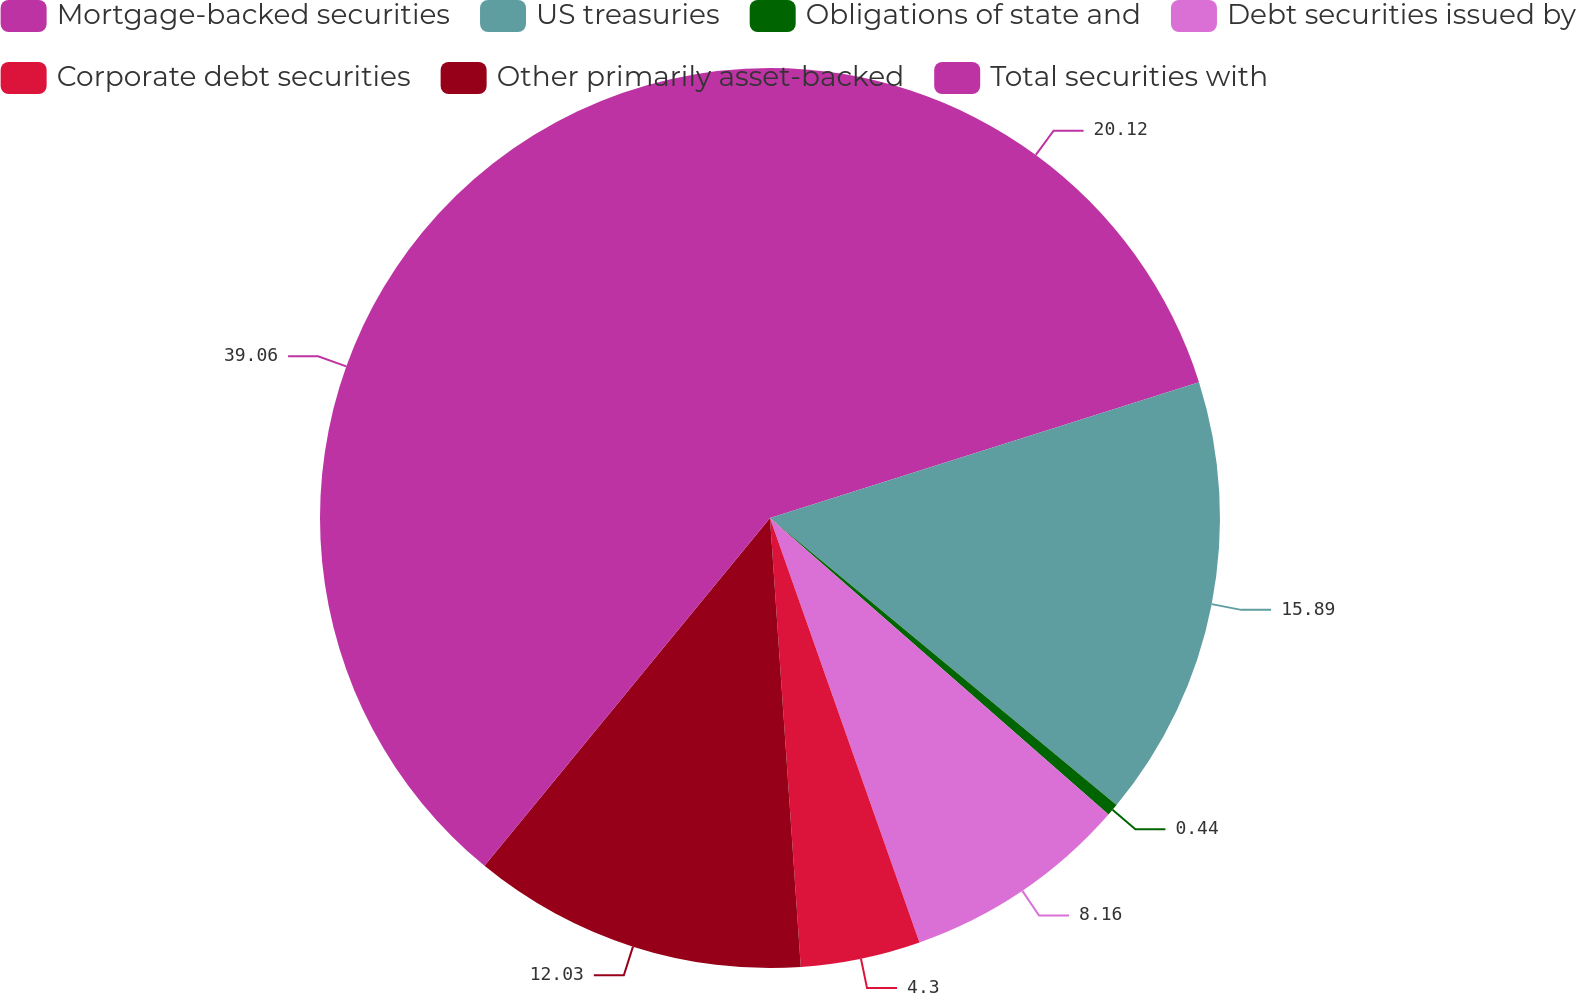<chart> <loc_0><loc_0><loc_500><loc_500><pie_chart><fcel>Mortgage-backed securities<fcel>US treasuries<fcel>Obligations of state and<fcel>Debt securities issued by<fcel>Corporate debt securities<fcel>Other primarily asset-backed<fcel>Total securities with<nl><fcel>20.12%<fcel>15.89%<fcel>0.44%<fcel>8.16%<fcel>4.3%<fcel>12.03%<fcel>39.06%<nl></chart> 